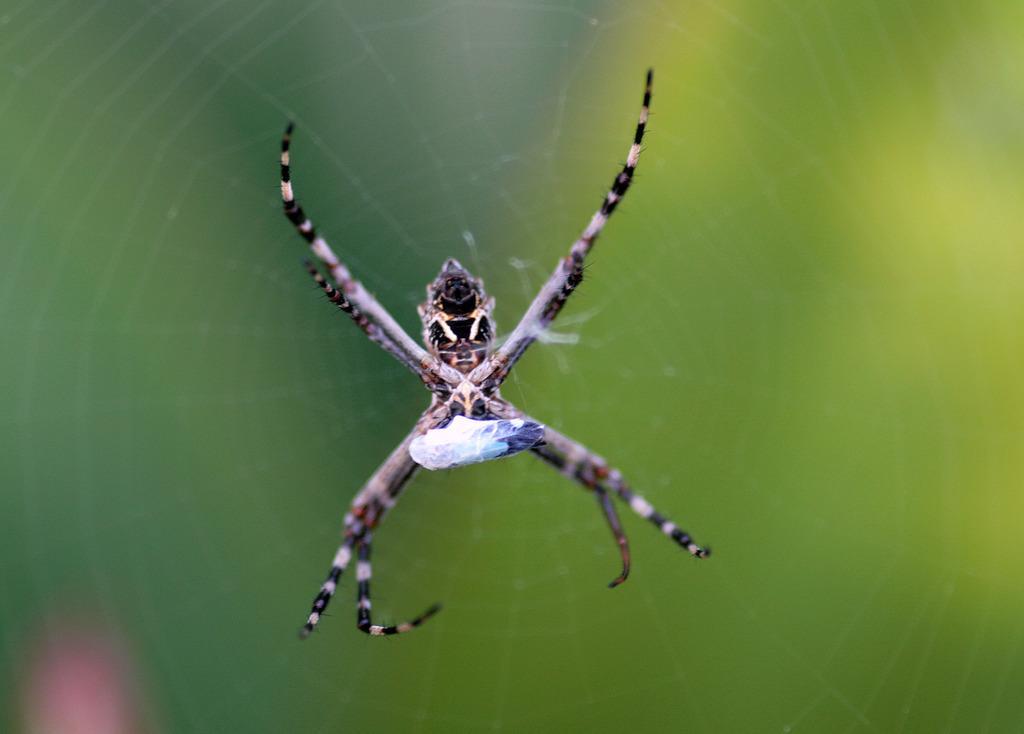How would you summarize this image in a sentence or two? In the foreground of this image, there is a spider on spider web. 